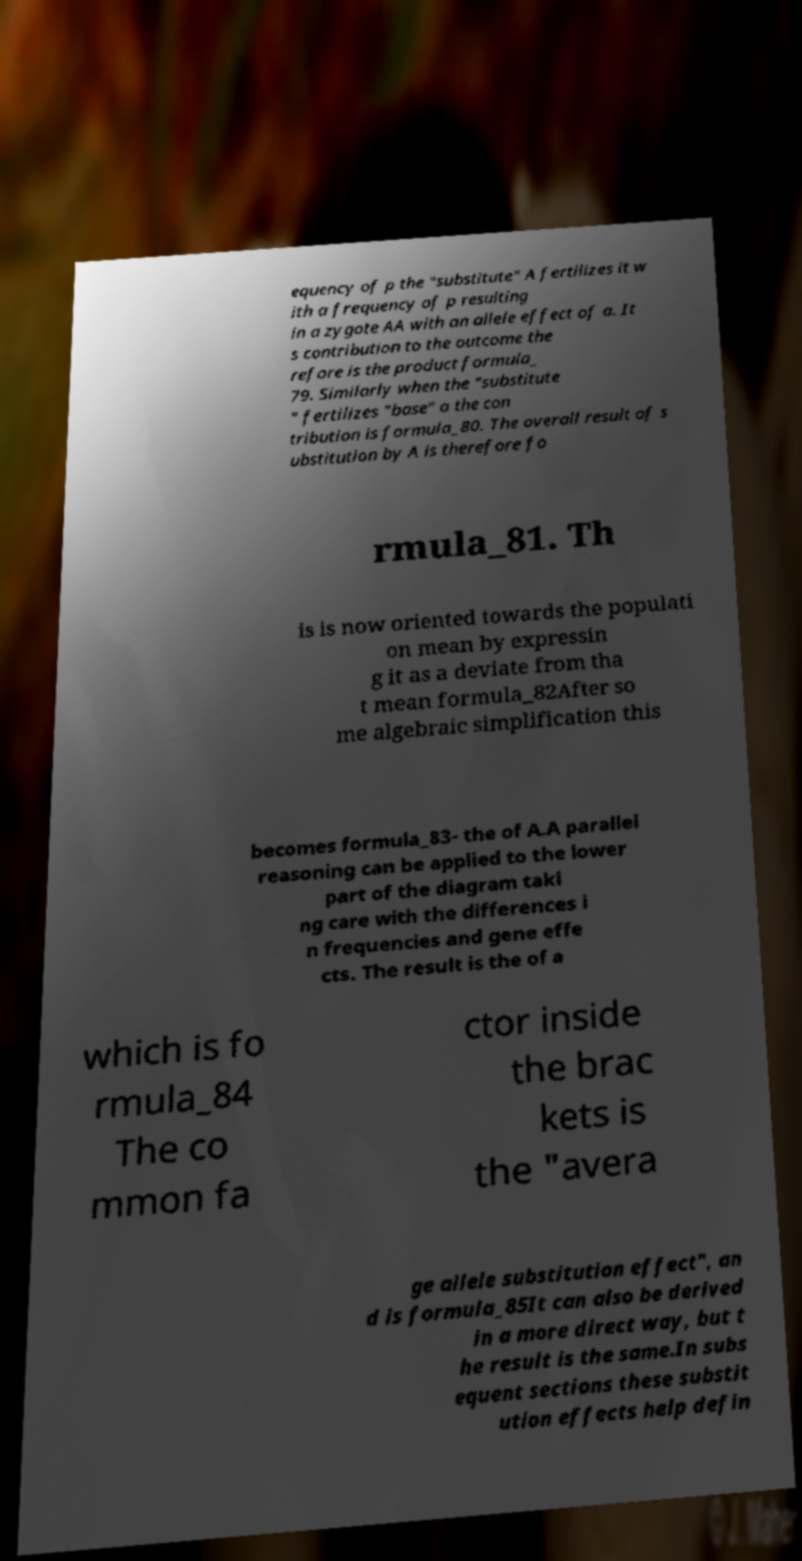Please read and relay the text visible in this image. What does it say? equency of p the "substitute" A fertilizes it w ith a frequency of p resulting in a zygote AA with an allele effect of a. It s contribution to the outcome the refore is the product formula_ 79. Similarly when the "substitute " fertilizes "base" a the con tribution is formula_80. The overall result of s ubstitution by A is therefore fo rmula_81. Th is is now oriented towards the populati on mean by expressin g it as a deviate from tha t mean formula_82After so me algebraic simplification this becomes formula_83- the of A.A parallel reasoning can be applied to the lower part of the diagram taki ng care with the differences i n frequencies and gene effe cts. The result is the of a which is fo rmula_84 The co mmon fa ctor inside the brac kets is the "avera ge allele substitution effect", an d is formula_85It can also be derived in a more direct way, but t he result is the same.In subs equent sections these substit ution effects help defin 